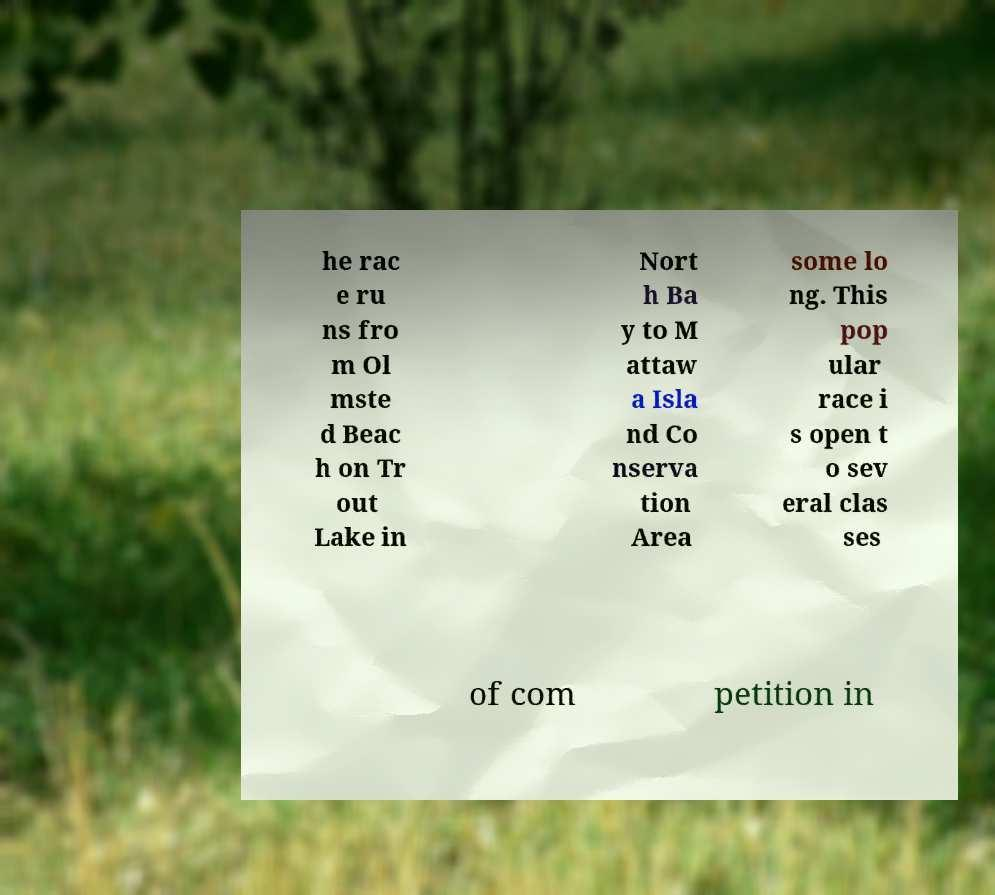Please read and relay the text visible in this image. What does it say? he rac e ru ns fro m Ol mste d Beac h on Tr out Lake in Nort h Ba y to M attaw a Isla nd Co nserva tion Area some lo ng. This pop ular race i s open t o sev eral clas ses of com petition in 